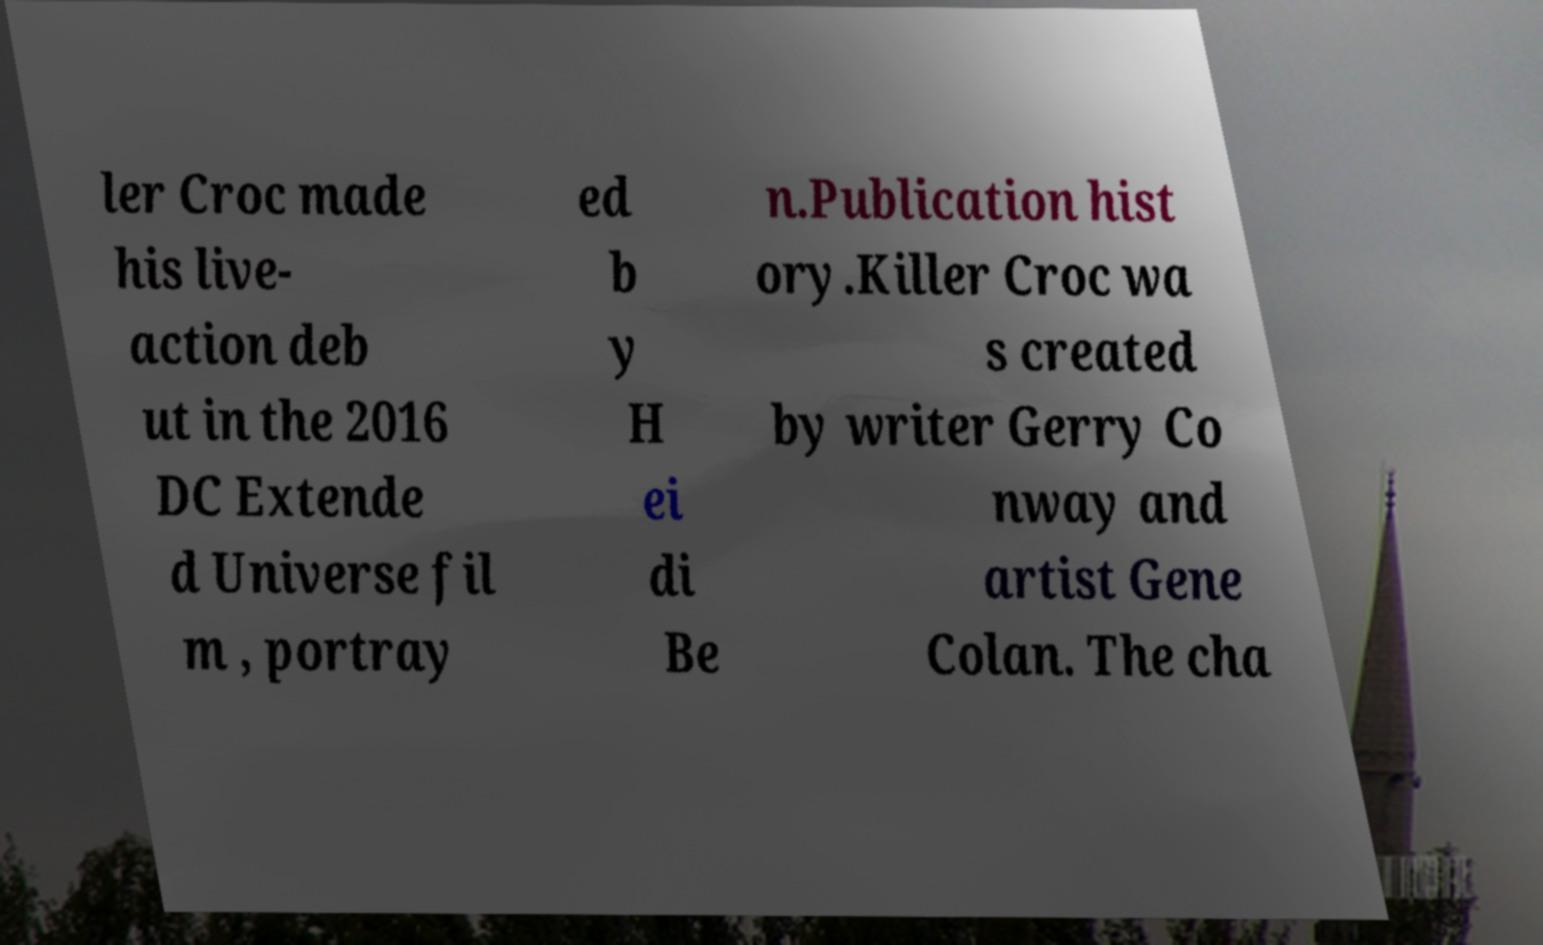Please read and relay the text visible in this image. What does it say? ler Croc made his live- action deb ut in the 2016 DC Extende d Universe fil m , portray ed b y H ei di Be n.Publication hist ory.Killer Croc wa s created by writer Gerry Co nway and artist Gene Colan. The cha 